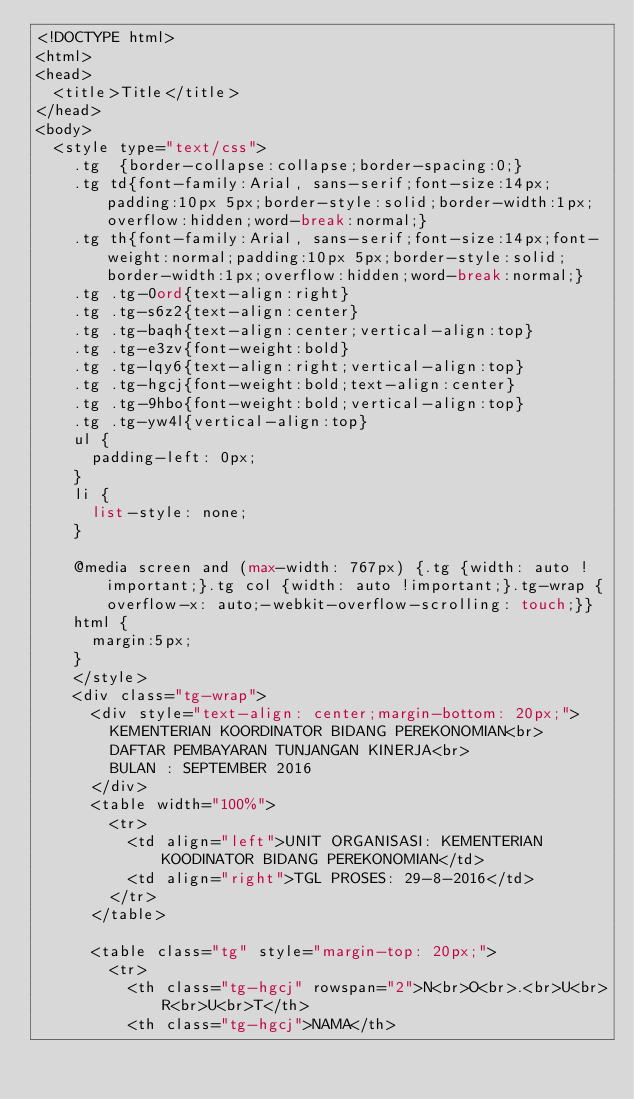Convert code to text. <code><loc_0><loc_0><loc_500><loc_500><_PHP_><!DOCTYPE html>
<html>
<head>
	<title>Title</title>
</head>
<body>
	<style type="text/css">
		.tg  {border-collapse:collapse;border-spacing:0;}
		.tg td{font-family:Arial, sans-serif;font-size:14px;padding:10px 5px;border-style:solid;border-width:1px;overflow:hidden;word-break:normal;}
		.tg th{font-family:Arial, sans-serif;font-size:14px;font-weight:normal;padding:10px 5px;border-style:solid;border-width:1px;overflow:hidden;word-break:normal;}
		.tg .tg-0ord{text-align:right}
		.tg .tg-s6z2{text-align:center}
		.tg .tg-baqh{text-align:center;vertical-align:top}
		.tg .tg-e3zv{font-weight:bold}
		.tg .tg-lqy6{text-align:right;vertical-align:top}
		.tg .tg-hgcj{font-weight:bold;text-align:center}
		.tg .tg-9hbo{font-weight:bold;vertical-align:top}
		.tg .tg-yw4l{vertical-align:top}
		ul {
			padding-left: 0px;
		}
		li {
			list-style: none;
		}

		@media screen and (max-width: 767px) {.tg {width: auto !important;}.tg col {width: auto !important;}.tg-wrap {overflow-x: auto;-webkit-overflow-scrolling: touch;}}
		html {
			margin:5px;
		}
		</style>
		<div class="tg-wrap">
			<div style="text-align: center;margin-bottom: 20px;">
				KEMENTERIAN KOORDINATOR BIDANG PEREKONOMIAN<br>
				DAFTAR PEMBAYARAN TUNJANGAN KINERJA<br>
				BULAN : SEPTEMBER 2016
			</div>
			<table width="100%">
				<tr>
					<td align="left">UNIT ORGANISASI: KEMENTERIAN KOODINATOR BIDANG PEREKONOMIAN</td>
					<td align="right">TGL PROSES: 29-8-2016</td>
				</tr>
			</table>

			<table class="tg" style="margin-top: 20px;">
				<tr>
					<th class="tg-hgcj" rowspan="2">N<br>O<br>.<br>U<br>R<br>U<br>T</th>
					<th class="tg-hgcj">NAMA</th></code> 